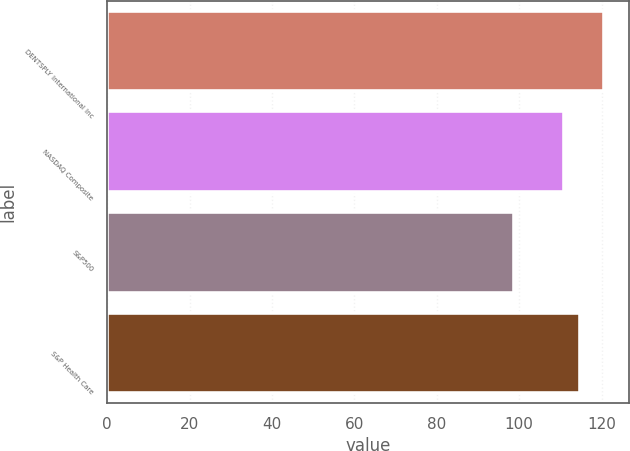Convert chart to OTSL. <chart><loc_0><loc_0><loc_500><loc_500><bar_chart><fcel>DENTSPLY International Inc<fcel>NASDAQ Composite<fcel>S&P500<fcel>S&P Health Care<nl><fcel>120.56<fcel>110.81<fcel>98.75<fcel>114.85<nl></chart> 